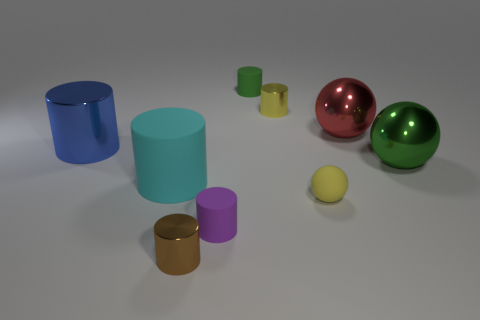Subtract all big cylinders. How many cylinders are left? 4 Subtract all spheres. How many objects are left? 6 Subtract 1 cylinders. How many cylinders are left? 5 Subtract all blue cylinders. How many cylinders are left? 5 Subtract all green things. Subtract all small brown metal things. How many objects are left? 6 Add 8 big green balls. How many big green balls are left? 9 Add 5 tiny brown matte balls. How many tiny brown matte balls exist? 5 Subtract 0 brown blocks. How many objects are left? 9 Subtract all gray cylinders. Subtract all brown spheres. How many cylinders are left? 6 Subtract all blue blocks. How many brown cylinders are left? 1 